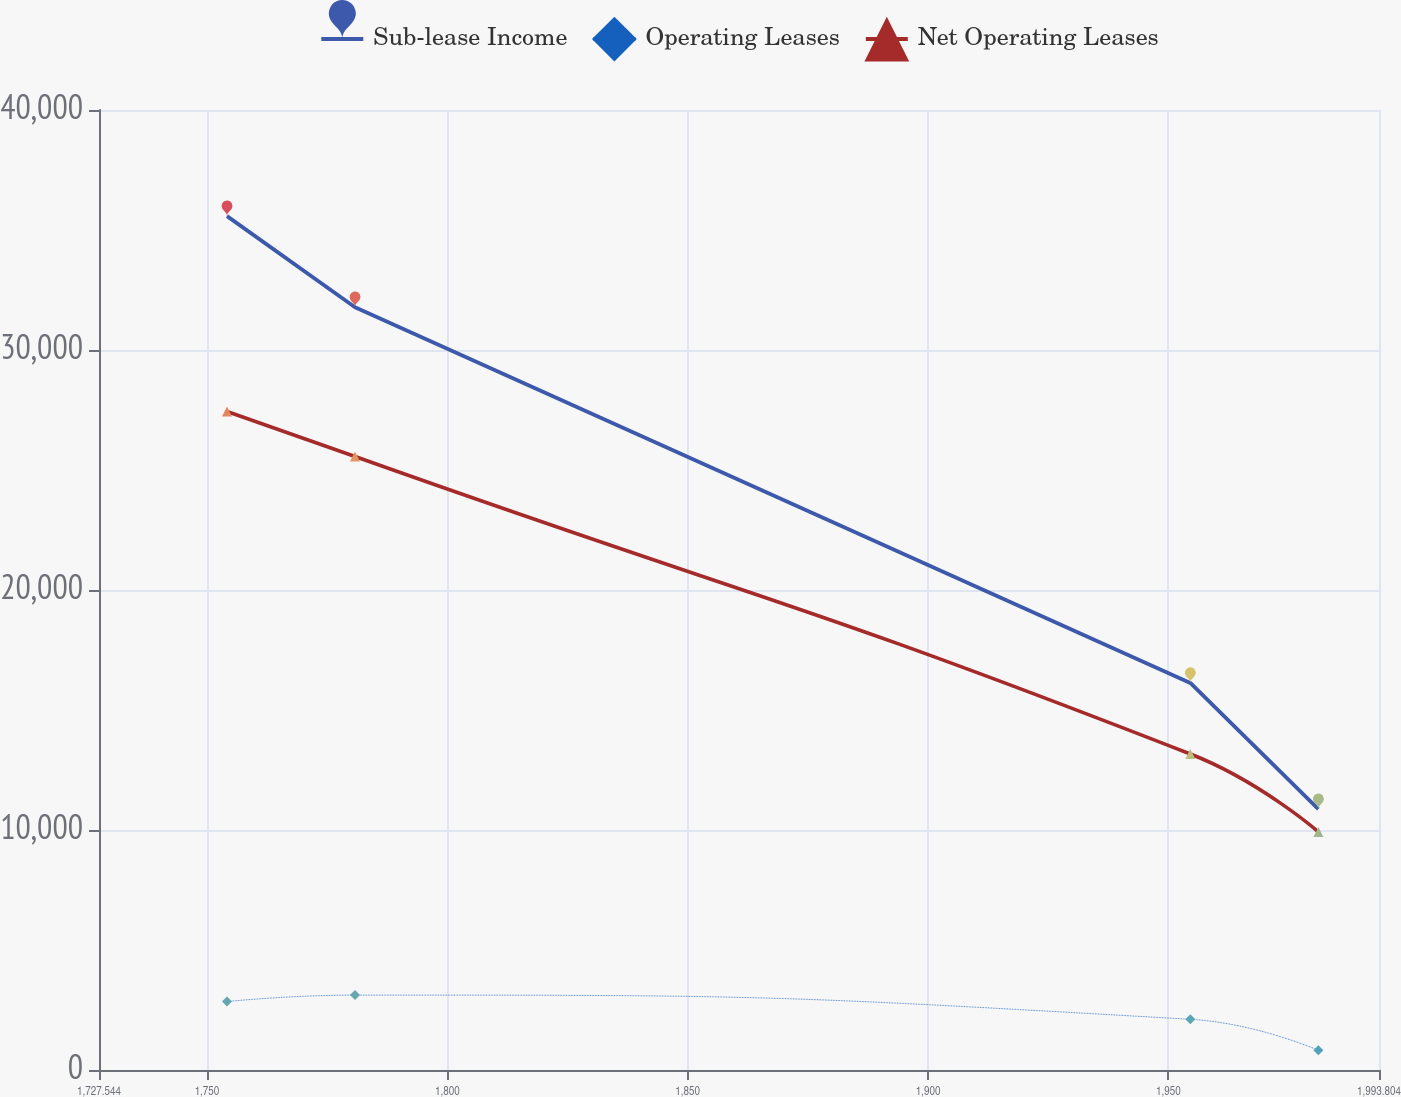<chart> <loc_0><loc_0><loc_500><loc_500><line_chart><ecel><fcel>Sub-lease Income<fcel>Operating Leases<fcel>Net Operating Leases<nl><fcel>1754.17<fcel>35576.5<fcel>2852.65<fcel>27436.6<nl><fcel>1780.8<fcel>31783.2<fcel>3121.5<fcel>25562.5<nl><fcel>1954.56<fcel>16129<fcel>2112.65<fcel>13167<nl><fcel>1981.19<fcel>10870.6<fcel>820.38<fcel>9920.91<nl><fcel>2020.43<fcel>6960.22<fcel>1050.49<fcel>8046.85<nl></chart> 